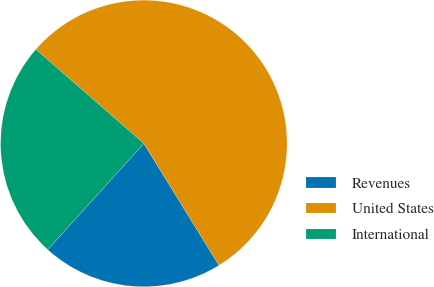Convert chart. <chart><loc_0><loc_0><loc_500><loc_500><pie_chart><fcel>Revenues<fcel>United States<fcel>International<nl><fcel>20.51%<fcel>54.79%<fcel>24.7%<nl></chart> 